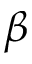Convert formula to latex. <formula><loc_0><loc_0><loc_500><loc_500>\beta</formula> 